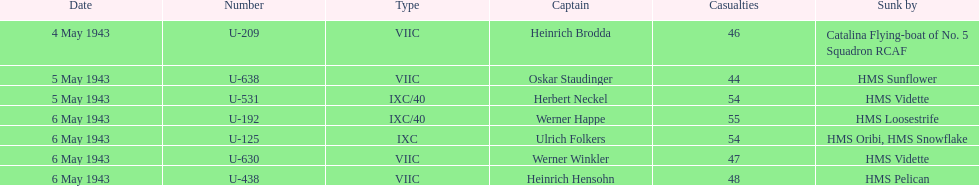On what date did at least 55 fatalities occur? 6 May 1943. 